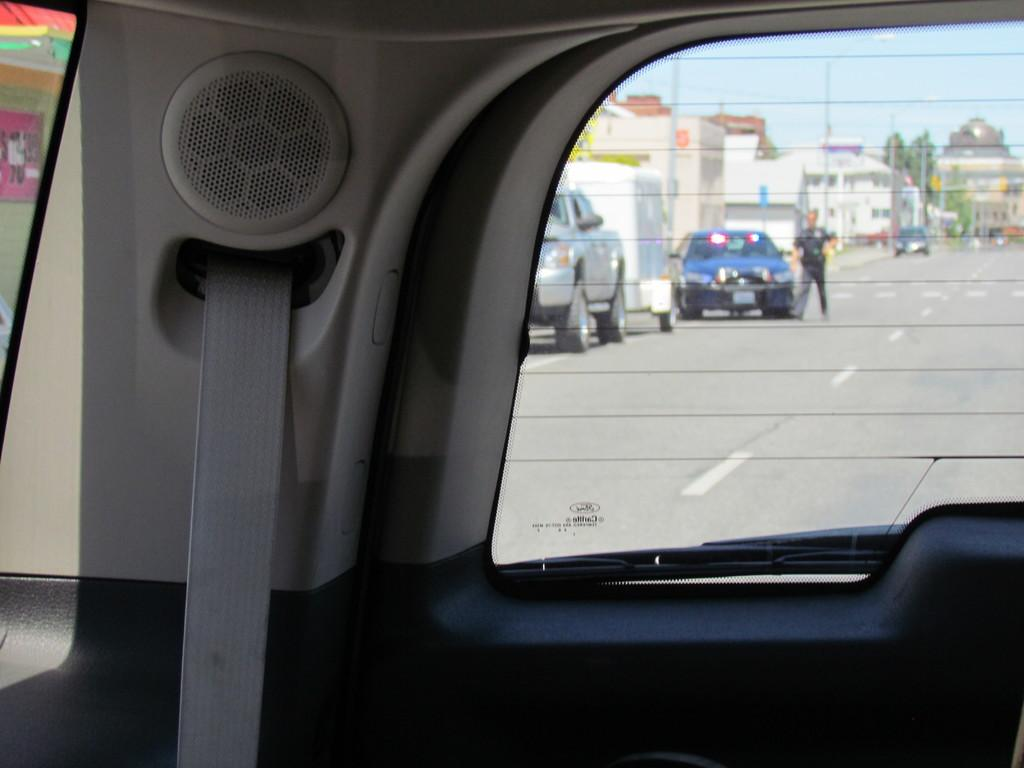Where was the image taken from? The image was taken from inside a car. What can be seen outside the car in the image? There are cars, buildings, a pole, trees, and the sky visible in the image. Can you describe the person in the image? There is a person in the image, but no specific details about their appearance or actions are provided. What type of rifle is the person holding in the image? There is no rifle present in the image; it only shows a person inside a car with various objects visible outside. 